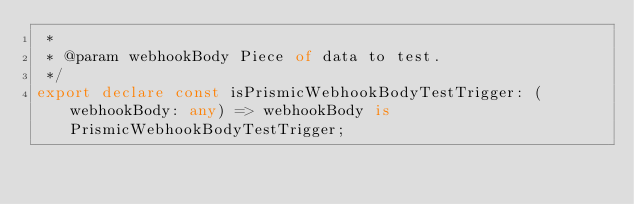Convert code to text. <code><loc_0><loc_0><loc_500><loc_500><_TypeScript_> *
 * @param webhookBody Piece of data to test.
 */
export declare const isPrismicWebhookBodyTestTrigger: (webhookBody: any) => webhookBody is PrismicWebhookBodyTestTrigger;
</code> 